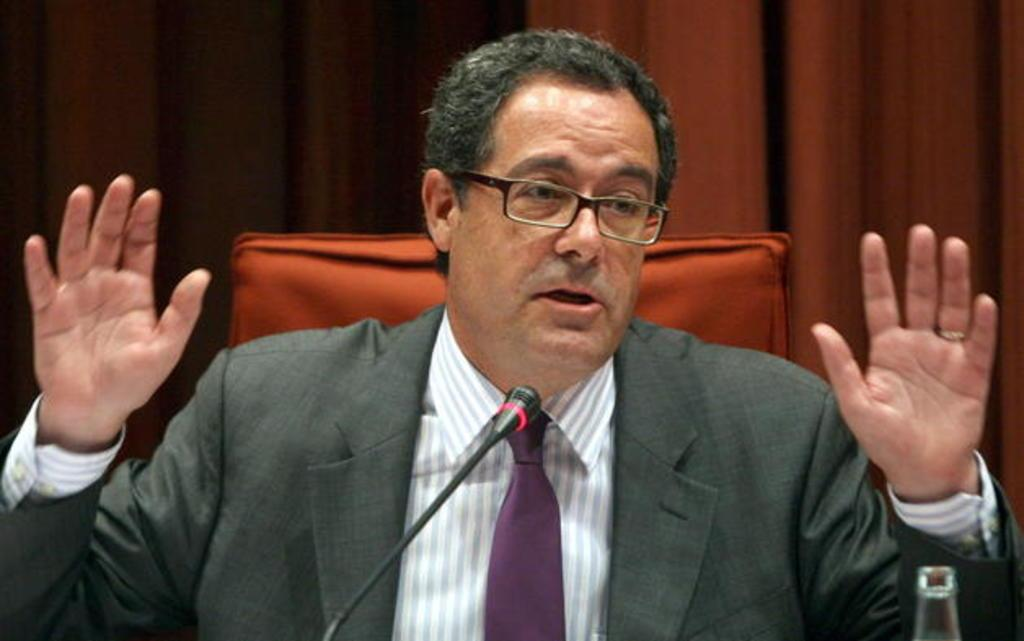Who or what is present in the image? There is a person in the image. What can be observed about the person's appearance? The person is wearing glasses (specs). What object is in front of the person? There is a microphone (mic) in front of the person. Can you describe any other objects in the image? Part of a bottle is visible in the image, and there is a curtain in the background. What type of furniture is present in the image? There is a chair in the image. What type of wool is being spun by the person in the image? There is no wool or spinning activity present in the image; the person is wearing glasses and there is a microphone in front of them. 